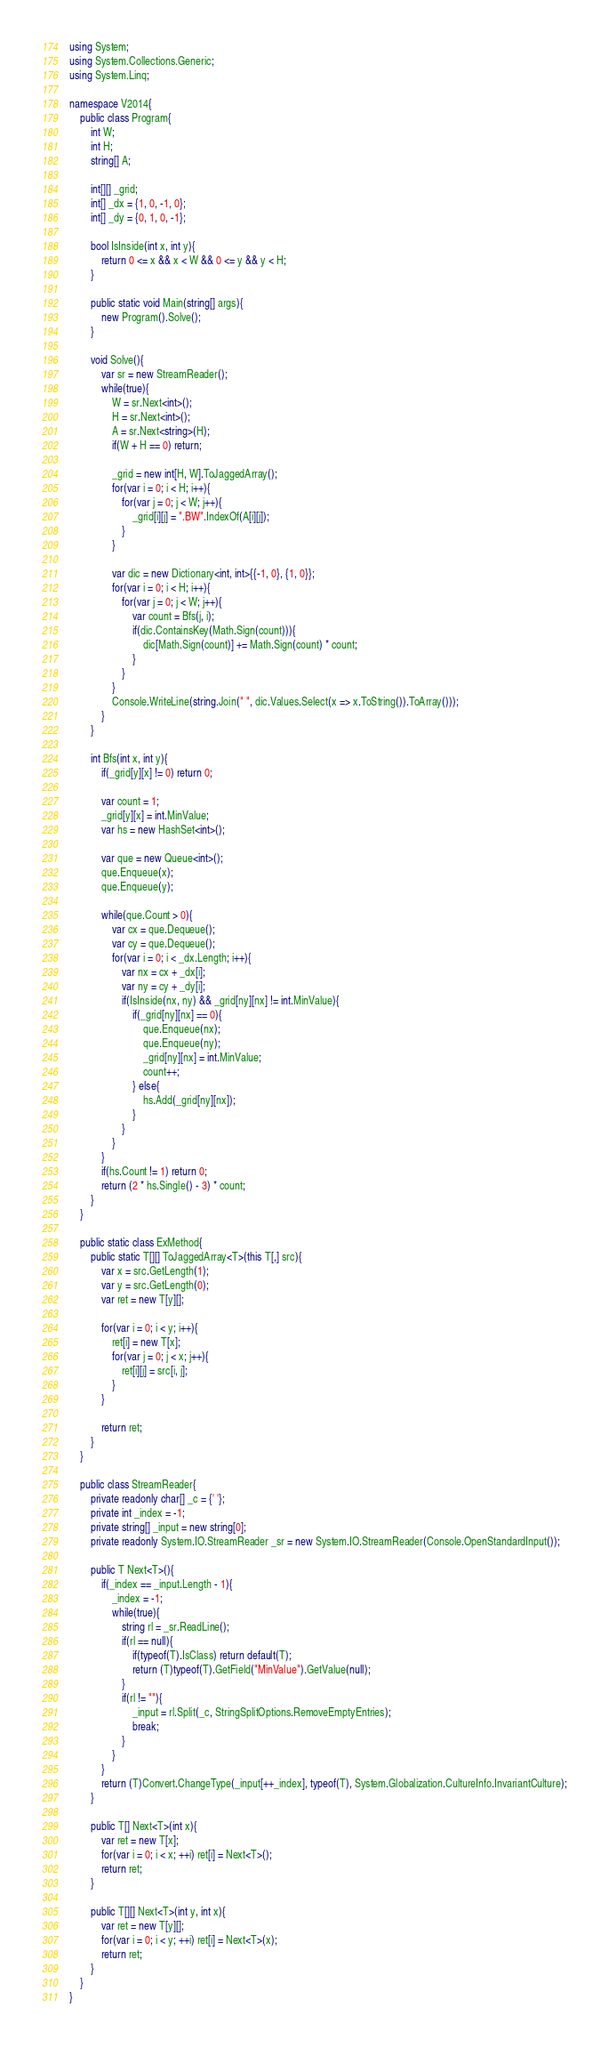<code> <loc_0><loc_0><loc_500><loc_500><_C#_>using System;
using System.Collections.Generic;
using System.Linq;

namespace V2014{
    public class Program{
        int W;
        int H;
        string[] A;

        int[][] _grid;
        int[] _dx = {1, 0, -1, 0};
        int[] _dy = {0, 1, 0, -1};

        bool IsInside(int x, int y){
            return 0 <= x && x < W && 0 <= y && y < H;
        }

        public static void Main(string[] args){
            new Program().Solve();
        }

        void Solve(){
            var sr = new StreamReader();
            while(true){
                W = sr.Next<int>();
                H = sr.Next<int>();
                A = sr.Next<string>(H);
                if(W + H == 0) return;

                _grid = new int[H, W].ToJaggedArray();
                for(var i = 0; i < H; i++){
                    for(var j = 0; j < W; j++){
                        _grid[i][j] = ".BW".IndexOf(A[i][j]);
                    }
                }

                var dic = new Dictionary<int, int>{{-1, 0}, {1, 0}};
                for(var i = 0; i < H; i++){
                    for(var j = 0; j < W; j++){
                        var count = Bfs(j, i);
                        if(dic.ContainsKey(Math.Sign(count))){
                            dic[Math.Sign(count)] += Math.Sign(count) * count;
                        }
                    }
                }
                Console.WriteLine(string.Join(" ", dic.Values.Select(x => x.ToString()).ToArray()));
            }
        }

        int Bfs(int x, int y){
            if(_grid[y][x] != 0) return 0;

            var count = 1;
            _grid[y][x] = int.MinValue;
            var hs = new HashSet<int>();

            var que = new Queue<int>();
            que.Enqueue(x);
            que.Enqueue(y);

            while(que.Count > 0){
                var cx = que.Dequeue();
                var cy = que.Dequeue();
                for(var i = 0; i < _dx.Length; i++){
                    var nx = cx + _dx[i];
                    var ny = cy + _dy[i];
                    if(IsInside(nx, ny) && _grid[ny][nx] != int.MinValue){
                        if(_grid[ny][nx] == 0){
                            que.Enqueue(nx);
                            que.Enqueue(ny);
                            _grid[ny][nx] = int.MinValue;
                            count++;
                        } else{
                            hs.Add(_grid[ny][nx]);
                        }
                    }
                }
            }
            if(hs.Count != 1) return 0;
            return (2 * hs.Single() - 3) * count;
        }
    }

    public static class ExMethod{
        public static T[][] ToJaggedArray<T>(this T[,] src){
            var x = src.GetLength(1);
            var y = src.GetLength(0);
            var ret = new T[y][];

            for(var i = 0; i < y; i++){
                ret[i] = new T[x];
                for(var j = 0; j < x; j++){
                    ret[i][j] = src[i, j];
                }
            }

            return ret;
        }
    }

    public class StreamReader{
        private readonly char[] _c = {' '};
        private int _index = -1;
        private string[] _input = new string[0];
        private readonly System.IO.StreamReader _sr = new System.IO.StreamReader(Console.OpenStandardInput());

        public T Next<T>(){
            if(_index == _input.Length - 1){
                _index = -1;
                while(true){
                    string rl = _sr.ReadLine();
                    if(rl == null){
                        if(typeof(T).IsClass) return default(T);
                        return (T)typeof(T).GetField("MinValue").GetValue(null);
                    }
                    if(rl != ""){
                        _input = rl.Split(_c, StringSplitOptions.RemoveEmptyEntries);
                        break;
                    }
                }
            }
            return (T)Convert.ChangeType(_input[++_index], typeof(T), System.Globalization.CultureInfo.InvariantCulture);
        }

        public T[] Next<T>(int x){
            var ret = new T[x];
            for(var i = 0; i < x; ++i) ret[i] = Next<T>();
            return ret;
        }

        public T[][] Next<T>(int y, int x){
            var ret = new T[y][];
            for(var i = 0; i < y; ++i) ret[i] = Next<T>(x);
            return ret;
        }
    }
}</code> 